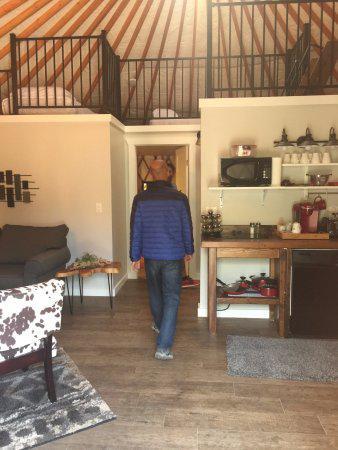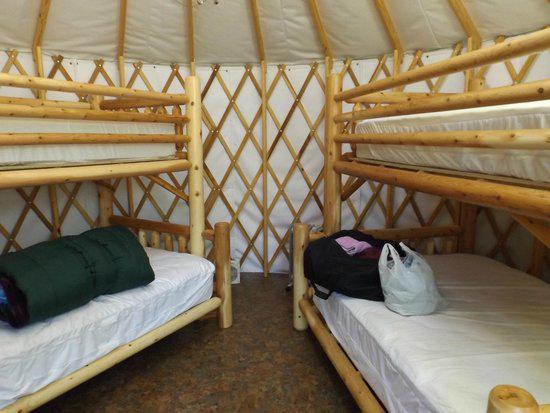The first image is the image on the left, the second image is the image on the right. For the images shown, is this caption "There is wooden floor in both images." true? Answer yes or no. No. The first image is the image on the left, the second image is the image on the right. Evaluate the accuracy of this statement regarding the images: "The image on the right contains at least one set of bunk beds.". Is it true? Answer yes or no. Yes. 